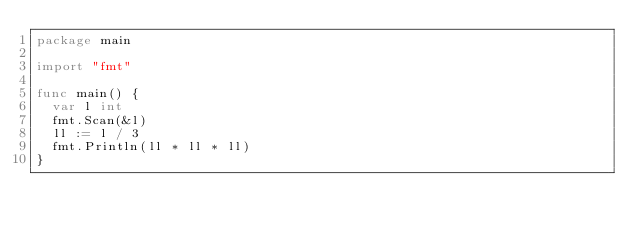<code> <loc_0><loc_0><loc_500><loc_500><_Go_>package main

import "fmt"

func main() {
	var l int
	fmt.Scan(&l)
	ll := l / 3
	fmt.Println(ll * ll * ll)
}
</code> 